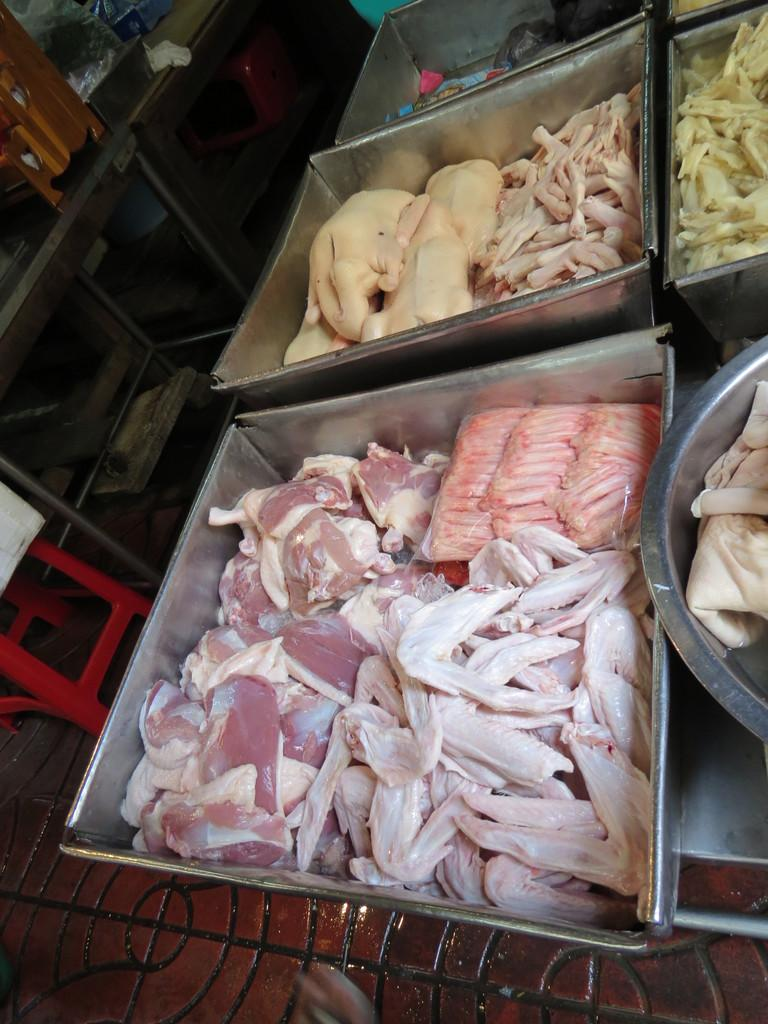What type of items can be seen in the trays in the image? There are food items in trays in the image. What is at the bottom of the image? The bottom of the image contains the floor. Can you describe a specific piece of furniture in the image? There is a red color stool in the image. What other objects can be seen in the image besides the food items and stool? There are other objects present in the image. How many ladybugs are crawling on the food items in the image? There are no ladybugs present in the image. What level of experience does the beginner have with the food items in the image? The image does not provide information about the experience level of any individuals, including beginners. 